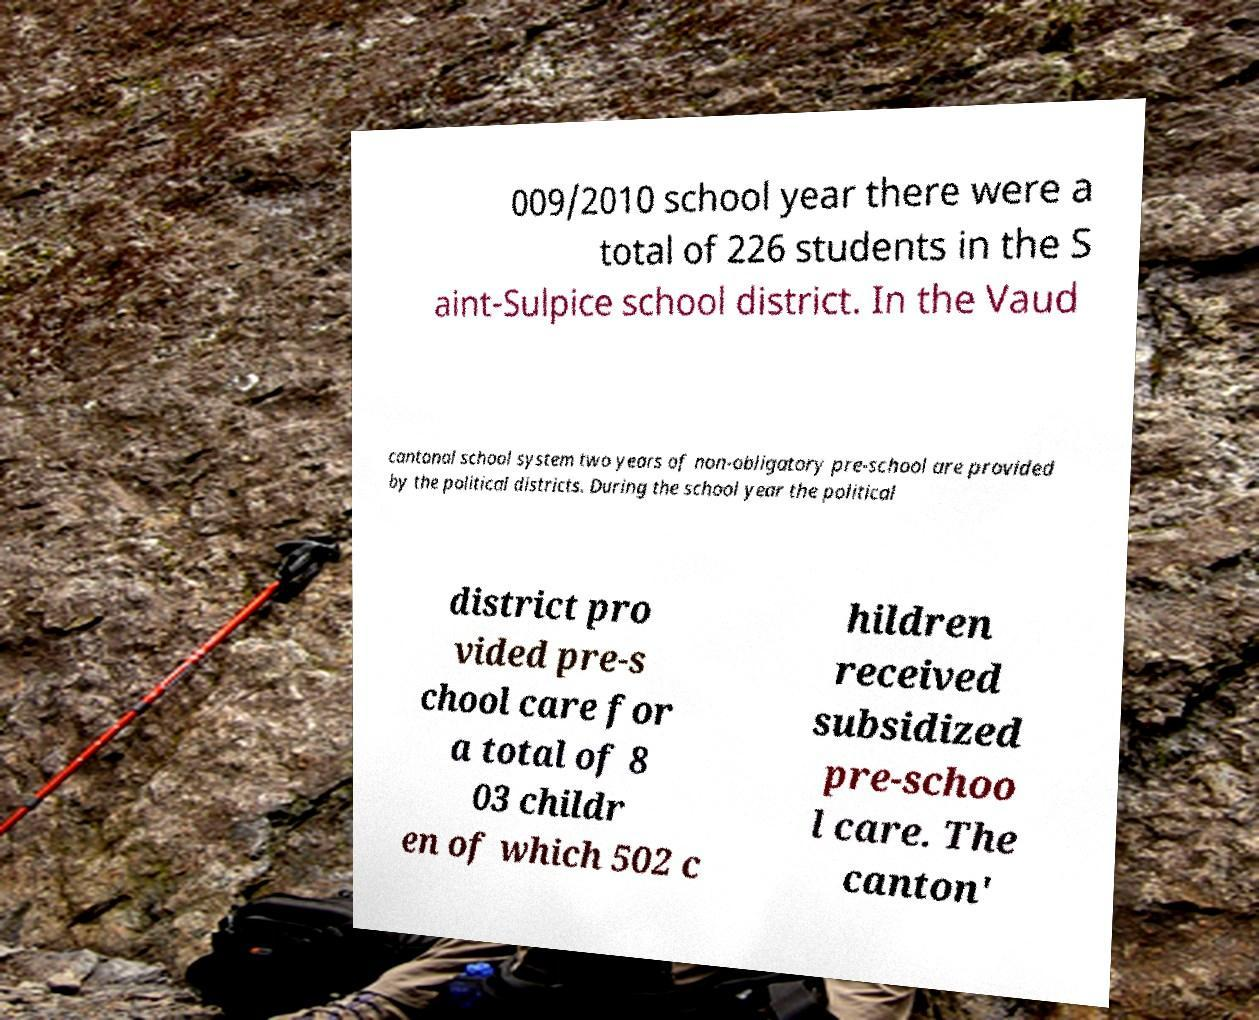There's text embedded in this image that I need extracted. Can you transcribe it verbatim? 009/2010 school year there were a total of 226 students in the S aint-Sulpice school district. In the Vaud cantonal school system two years of non-obligatory pre-school are provided by the political districts. During the school year the political district pro vided pre-s chool care for a total of 8 03 childr en of which 502 c hildren received subsidized pre-schoo l care. The canton' 